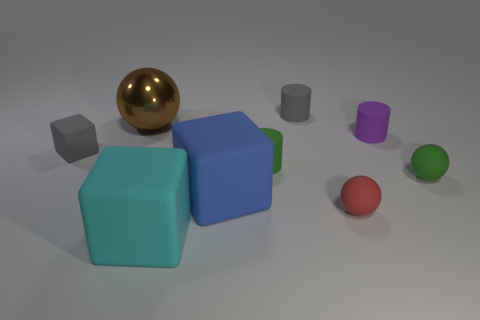Add 1 gray cylinders. How many objects exist? 10 Subtract all cubes. How many objects are left? 6 Add 6 large things. How many large things exist? 9 Subtract 0 purple spheres. How many objects are left? 9 Subtract all large blue things. Subtract all matte blocks. How many objects are left? 5 Add 5 gray rubber objects. How many gray rubber objects are left? 7 